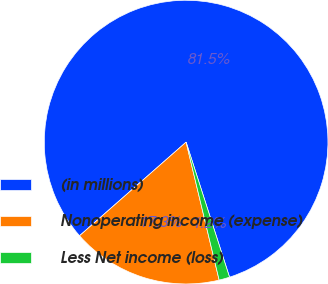Convert chart to OTSL. <chart><loc_0><loc_0><loc_500><loc_500><pie_chart><fcel>(in millions)<fcel>Nonoperating income (expense)<fcel>Less Net income (loss)<nl><fcel>81.51%<fcel>17.27%<fcel>1.21%<nl></chart> 